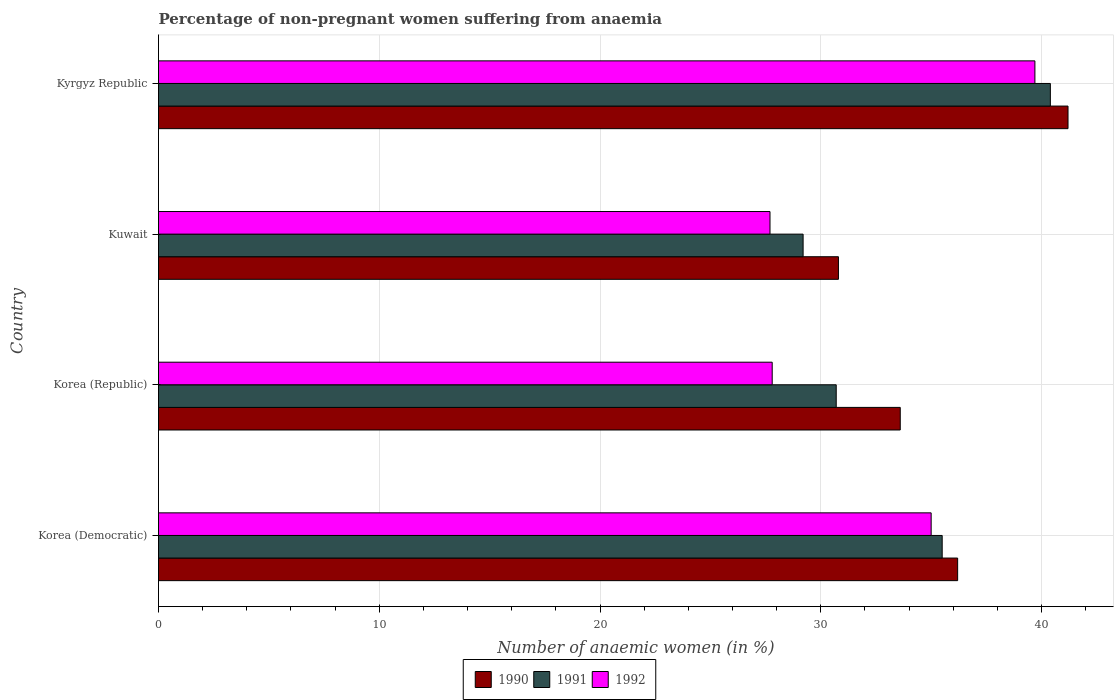How many bars are there on the 1st tick from the top?
Offer a terse response. 3. What is the label of the 1st group of bars from the top?
Give a very brief answer. Kyrgyz Republic. What is the percentage of non-pregnant women suffering from anaemia in 1990 in Korea (Republic)?
Offer a terse response. 33.6. Across all countries, what is the maximum percentage of non-pregnant women suffering from anaemia in 1990?
Provide a succinct answer. 41.2. Across all countries, what is the minimum percentage of non-pregnant women suffering from anaemia in 1991?
Offer a terse response. 29.2. In which country was the percentage of non-pregnant women suffering from anaemia in 1990 maximum?
Make the answer very short. Kyrgyz Republic. In which country was the percentage of non-pregnant women suffering from anaemia in 1992 minimum?
Provide a short and direct response. Kuwait. What is the total percentage of non-pregnant women suffering from anaemia in 1990 in the graph?
Your response must be concise. 141.8. What is the difference between the percentage of non-pregnant women suffering from anaemia in 1992 in Korea (Republic) and that in Kuwait?
Provide a succinct answer. 0.1. What is the difference between the percentage of non-pregnant women suffering from anaemia in 1990 in Korea (Democratic) and the percentage of non-pregnant women suffering from anaemia in 1992 in Korea (Republic)?
Give a very brief answer. 8.4. What is the average percentage of non-pregnant women suffering from anaemia in 1992 per country?
Offer a terse response. 32.55. What is the difference between the percentage of non-pregnant women suffering from anaemia in 1992 and percentage of non-pregnant women suffering from anaemia in 1991 in Korea (Democratic)?
Give a very brief answer. -0.5. In how many countries, is the percentage of non-pregnant women suffering from anaemia in 1990 greater than 26 %?
Keep it short and to the point. 4. What is the ratio of the percentage of non-pregnant women suffering from anaemia in 1991 in Korea (Republic) to that in Kuwait?
Your answer should be compact. 1.05. Is the percentage of non-pregnant women suffering from anaemia in 1990 in Korea (Democratic) less than that in Korea (Republic)?
Keep it short and to the point. No. What is the difference between the highest and the lowest percentage of non-pregnant women suffering from anaemia in 1992?
Keep it short and to the point. 12. In how many countries, is the percentage of non-pregnant women suffering from anaemia in 1991 greater than the average percentage of non-pregnant women suffering from anaemia in 1991 taken over all countries?
Ensure brevity in your answer.  2. Is the sum of the percentage of non-pregnant women suffering from anaemia in 1990 in Korea (Democratic) and Korea (Republic) greater than the maximum percentage of non-pregnant women suffering from anaemia in 1991 across all countries?
Provide a succinct answer. Yes. What does the 3rd bar from the bottom in Korea (Democratic) represents?
Your answer should be compact. 1992. Is it the case that in every country, the sum of the percentage of non-pregnant women suffering from anaemia in 1991 and percentage of non-pregnant women suffering from anaemia in 1992 is greater than the percentage of non-pregnant women suffering from anaemia in 1990?
Provide a short and direct response. Yes. How many bars are there?
Provide a succinct answer. 12. Are all the bars in the graph horizontal?
Keep it short and to the point. Yes. How many countries are there in the graph?
Your response must be concise. 4. What is the difference between two consecutive major ticks on the X-axis?
Offer a terse response. 10. Does the graph contain any zero values?
Your answer should be compact. No. Does the graph contain grids?
Offer a terse response. Yes. Where does the legend appear in the graph?
Offer a terse response. Bottom center. How many legend labels are there?
Your answer should be compact. 3. How are the legend labels stacked?
Provide a succinct answer. Horizontal. What is the title of the graph?
Keep it short and to the point. Percentage of non-pregnant women suffering from anaemia. What is the label or title of the X-axis?
Provide a short and direct response. Number of anaemic women (in %). What is the label or title of the Y-axis?
Give a very brief answer. Country. What is the Number of anaemic women (in %) of 1990 in Korea (Democratic)?
Ensure brevity in your answer.  36.2. What is the Number of anaemic women (in %) of 1991 in Korea (Democratic)?
Give a very brief answer. 35.5. What is the Number of anaemic women (in %) of 1990 in Korea (Republic)?
Your answer should be very brief. 33.6. What is the Number of anaemic women (in %) of 1991 in Korea (Republic)?
Give a very brief answer. 30.7. What is the Number of anaemic women (in %) in 1992 in Korea (Republic)?
Your response must be concise. 27.8. What is the Number of anaemic women (in %) of 1990 in Kuwait?
Ensure brevity in your answer.  30.8. What is the Number of anaemic women (in %) in 1991 in Kuwait?
Your response must be concise. 29.2. What is the Number of anaemic women (in %) in 1992 in Kuwait?
Make the answer very short. 27.7. What is the Number of anaemic women (in %) of 1990 in Kyrgyz Republic?
Offer a very short reply. 41.2. What is the Number of anaemic women (in %) in 1991 in Kyrgyz Republic?
Offer a very short reply. 40.4. What is the Number of anaemic women (in %) of 1992 in Kyrgyz Republic?
Ensure brevity in your answer.  39.7. Across all countries, what is the maximum Number of anaemic women (in %) of 1990?
Offer a terse response. 41.2. Across all countries, what is the maximum Number of anaemic women (in %) in 1991?
Provide a succinct answer. 40.4. Across all countries, what is the maximum Number of anaemic women (in %) of 1992?
Offer a terse response. 39.7. Across all countries, what is the minimum Number of anaemic women (in %) of 1990?
Provide a succinct answer. 30.8. Across all countries, what is the minimum Number of anaemic women (in %) in 1991?
Make the answer very short. 29.2. Across all countries, what is the minimum Number of anaemic women (in %) in 1992?
Offer a terse response. 27.7. What is the total Number of anaemic women (in %) of 1990 in the graph?
Offer a terse response. 141.8. What is the total Number of anaemic women (in %) of 1991 in the graph?
Your answer should be very brief. 135.8. What is the total Number of anaemic women (in %) in 1992 in the graph?
Give a very brief answer. 130.2. What is the difference between the Number of anaemic women (in %) of 1990 in Korea (Democratic) and that in Korea (Republic)?
Provide a succinct answer. 2.6. What is the difference between the Number of anaemic women (in %) of 1991 in Korea (Democratic) and that in Kuwait?
Provide a succinct answer. 6.3. What is the difference between the Number of anaemic women (in %) of 1990 in Korea (Democratic) and that in Kyrgyz Republic?
Your response must be concise. -5. What is the difference between the Number of anaemic women (in %) of 1991 in Korea (Democratic) and that in Kyrgyz Republic?
Your answer should be compact. -4.9. What is the difference between the Number of anaemic women (in %) of 1992 in Korea (Democratic) and that in Kyrgyz Republic?
Give a very brief answer. -4.7. What is the difference between the Number of anaemic women (in %) of 1990 in Korea (Republic) and that in Kuwait?
Provide a short and direct response. 2.8. What is the difference between the Number of anaemic women (in %) of 1992 in Korea (Republic) and that in Kuwait?
Ensure brevity in your answer.  0.1. What is the difference between the Number of anaemic women (in %) of 1990 in Korea (Democratic) and the Number of anaemic women (in %) of 1992 in Kuwait?
Give a very brief answer. 8.5. What is the difference between the Number of anaemic women (in %) in 1990 in Korea (Democratic) and the Number of anaemic women (in %) in 1992 in Kyrgyz Republic?
Make the answer very short. -3.5. What is the difference between the Number of anaemic women (in %) in 1990 in Korea (Republic) and the Number of anaemic women (in %) in 1991 in Kuwait?
Offer a terse response. 4.4. What is the difference between the Number of anaemic women (in %) of 1990 in Korea (Republic) and the Number of anaemic women (in %) of 1991 in Kyrgyz Republic?
Provide a succinct answer. -6.8. What is the difference between the Number of anaemic women (in %) in 1990 in Korea (Republic) and the Number of anaemic women (in %) in 1992 in Kyrgyz Republic?
Ensure brevity in your answer.  -6.1. What is the difference between the Number of anaemic women (in %) of 1991 in Korea (Republic) and the Number of anaemic women (in %) of 1992 in Kyrgyz Republic?
Your answer should be very brief. -9. What is the difference between the Number of anaemic women (in %) in 1990 in Kuwait and the Number of anaemic women (in %) in 1992 in Kyrgyz Republic?
Give a very brief answer. -8.9. What is the average Number of anaemic women (in %) of 1990 per country?
Ensure brevity in your answer.  35.45. What is the average Number of anaemic women (in %) in 1991 per country?
Make the answer very short. 33.95. What is the average Number of anaemic women (in %) of 1992 per country?
Offer a terse response. 32.55. What is the difference between the Number of anaemic women (in %) of 1990 and Number of anaemic women (in %) of 1992 in Korea (Democratic)?
Your response must be concise. 1.2. What is the difference between the Number of anaemic women (in %) of 1991 and Number of anaemic women (in %) of 1992 in Korea (Democratic)?
Provide a succinct answer. 0.5. What is the difference between the Number of anaemic women (in %) in 1990 and Number of anaemic women (in %) in 1991 in Korea (Republic)?
Give a very brief answer. 2.9. What is the difference between the Number of anaemic women (in %) in 1990 and Number of anaemic women (in %) in 1992 in Korea (Republic)?
Provide a succinct answer. 5.8. What is the difference between the Number of anaemic women (in %) in 1990 and Number of anaemic women (in %) in 1991 in Kyrgyz Republic?
Your response must be concise. 0.8. What is the difference between the Number of anaemic women (in %) in 1991 and Number of anaemic women (in %) in 1992 in Kyrgyz Republic?
Your answer should be compact. 0.7. What is the ratio of the Number of anaemic women (in %) of 1990 in Korea (Democratic) to that in Korea (Republic)?
Make the answer very short. 1.08. What is the ratio of the Number of anaemic women (in %) in 1991 in Korea (Democratic) to that in Korea (Republic)?
Provide a short and direct response. 1.16. What is the ratio of the Number of anaemic women (in %) of 1992 in Korea (Democratic) to that in Korea (Republic)?
Your response must be concise. 1.26. What is the ratio of the Number of anaemic women (in %) in 1990 in Korea (Democratic) to that in Kuwait?
Give a very brief answer. 1.18. What is the ratio of the Number of anaemic women (in %) in 1991 in Korea (Democratic) to that in Kuwait?
Ensure brevity in your answer.  1.22. What is the ratio of the Number of anaemic women (in %) of 1992 in Korea (Democratic) to that in Kuwait?
Make the answer very short. 1.26. What is the ratio of the Number of anaemic women (in %) in 1990 in Korea (Democratic) to that in Kyrgyz Republic?
Your response must be concise. 0.88. What is the ratio of the Number of anaemic women (in %) of 1991 in Korea (Democratic) to that in Kyrgyz Republic?
Your response must be concise. 0.88. What is the ratio of the Number of anaemic women (in %) of 1992 in Korea (Democratic) to that in Kyrgyz Republic?
Provide a succinct answer. 0.88. What is the ratio of the Number of anaemic women (in %) in 1991 in Korea (Republic) to that in Kuwait?
Give a very brief answer. 1.05. What is the ratio of the Number of anaemic women (in %) in 1990 in Korea (Republic) to that in Kyrgyz Republic?
Provide a short and direct response. 0.82. What is the ratio of the Number of anaemic women (in %) in 1991 in Korea (Republic) to that in Kyrgyz Republic?
Provide a succinct answer. 0.76. What is the ratio of the Number of anaemic women (in %) in 1992 in Korea (Republic) to that in Kyrgyz Republic?
Your answer should be compact. 0.7. What is the ratio of the Number of anaemic women (in %) of 1990 in Kuwait to that in Kyrgyz Republic?
Ensure brevity in your answer.  0.75. What is the ratio of the Number of anaemic women (in %) of 1991 in Kuwait to that in Kyrgyz Republic?
Provide a short and direct response. 0.72. What is the ratio of the Number of anaemic women (in %) in 1992 in Kuwait to that in Kyrgyz Republic?
Make the answer very short. 0.7. What is the difference between the highest and the second highest Number of anaemic women (in %) in 1990?
Keep it short and to the point. 5. What is the difference between the highest and the second highest Number of anaemic women (in %) in 1991?
Ensure brevity in your answer.  4.9. What is the difference between the highest and the second highest Number of anaemic women (in %) of 1992?
Keep it short and to the point. 4.7. What is the difference between the highest and the lowest Number of anaemic women (in %) in 1990?
Provide a short and direct response. 10.4. 